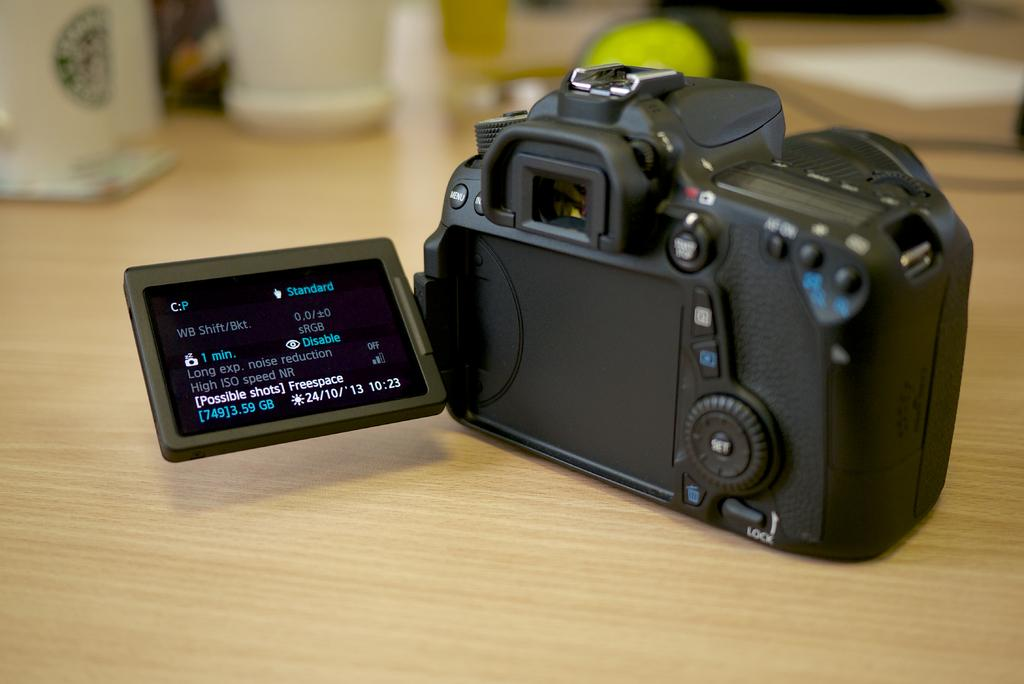What is the main object in the image? There is a camera in the image. What can be seen on the table in the image? There are other objects on the table in the image. What type of juice is being weighed in the image? There is no juice or any indication of weight measurement in the image. 